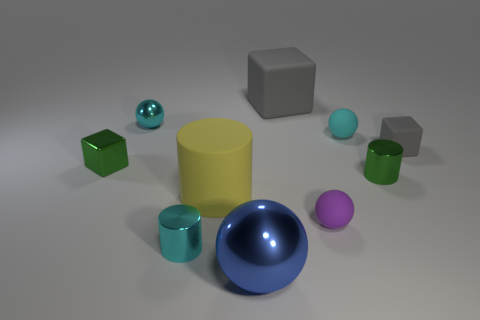Is there a pattern in the arrangement of these objects? There does not seem to be an evident pattern in the arrangement of the objects. They are spread out randomly across the surface. What can you infer about the lighting in this scene? The lighting appears uniform and diffuse, creating soft shadows under the objects, which suggests an indoor setting with ample ambient light, possibly from overhead sources. 